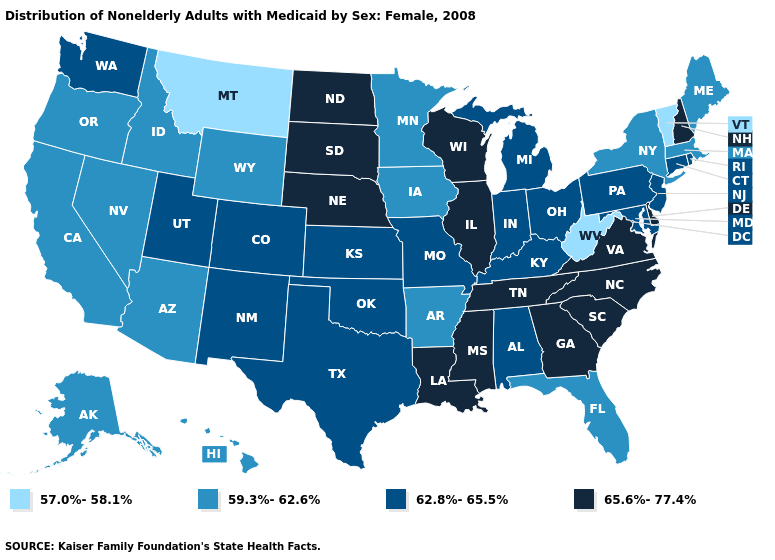What is the value of Massachusetts?
Give a very brief answer. 59.3%-62.6%. Among the states that border North Dakota , does South Dakota have the lowest value?
Write a very short answer. No. What is the highest value in the USA?
Concise answer only. 65.6%-77.4%. What is the value of Florida?
Give a very brief answer. 59.3%-62.6%. Name the states that have a value in the range 65.6%-77.4%?
Write a very short answer. Delaware, Georgia, Illinois, Louisiana, Mississippi, Nebraska, New Hampshire, North Carolina, North Dakota, South Carolina, South Dakota, Tennessee, Virginia, Wisconsin. What is the highest value in states that border Colorado?
Write a very short answer. 65.6%-77.4%. Which states have the lowest value in the West?
Be succinct. Montana. What is the lowest value in states that border Alabama?
Keep it brief. 59.3%-62.6%. Among the states that border California , which have the lowest value?
Answer briefly. Arizona, Nevada, Oregon. Does the map have missing data?
Give a very brief answer. No. How many symbols are there in the legend?
Keep it brief. 4. What is the value of Pennsylvania?
Give a very brief answer. 62.8%-65.5%. Among the states that border Indiana , does Ohio have the lowest value?
Concise answer only. Yes. Which states have the lowest value in the West?
Short answer required. Montana. What is the highest value in the USA?
Quick response, please. 65.6%-77.4%. 